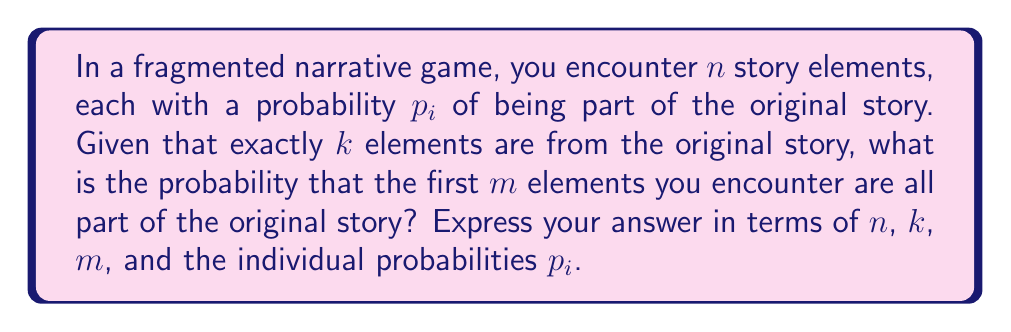Help me with this question. Let's approach this step-by-step:

1) First, we need to calculate the probability that all of the first $m$ elements are part of the original story. This is the product of their individual probabilities:

   $$P(\text{first m are original}) = \prod_{i=1}^m p_i$$

2) However, we also know that exactly $k$ elements are from the original story. So, we need to calculate the probability that the remaining $k-m$ elements are distributed among the remaining $n-m$ elements.

3) This is a combination problem. We need to choose $k-m$ elements from $n-m$ elements. The number of ways to do this is:

   $$\binom{n-m}{k-m}$$

4) For each of these combinations, we need to calculate the probability. This is the product of the probabilities of the chosen elements being original and the probabilities of the unchosen elements not being original:

   $$\prod_{i=m+1}^n p_i^{x_i}(1-p_i)^{1-x_i}$$

   where $x_i = 1$ if the $i$-th element is chosen, and 0 otherwise.

5) The total probability is the sum of these probabilities over all possible combinations:

   $$P(\text{first m are original | k total are original}) = \frac{\prod_{i=1}^m p_i \sum_{\text{comb}} \prod_{i=m+1}^n p_i^{x_i}(1-p_i)^{1-x_i}}{\binom{n}{k}\prod_{i=1}^n p_i^{y_i}(1-p_i)^{1-y_i}}$$

   where the sum is over all combinations of $k-m$ elements from $n-m$ elements, and $y_i = 1$ if the $i$-th element is part of the $k$ original elements, and 0 otherwise.

6) This formula gives us the conditional probability, given that exactly $k$ elements are from the original story.
Answer: $$\frac{\prod_{i=1}^m p_i \sum_{\text{comb}} \prod_{i=m+1}^n p_i^{x_i}(1-p_i)^{1-x_i}}{\binom{n}{k}\prod_{i=1}^n p_i^{y_i}(1-p_i)^{1-y_i}}$$ 